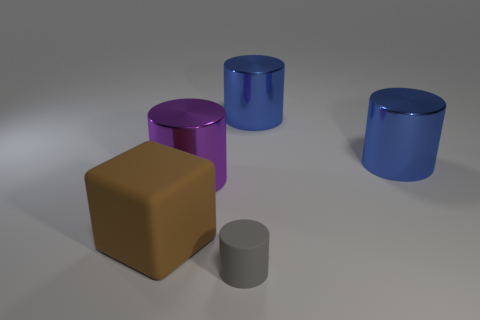Add 2 rubber cylinders. How many objects exist? 7 Subtract all blocks. How many objects are left? 4 Add 2 gray cylinders. How many gray cylinders exist? 3 Subtract 0 cyan cylinders. How many objects are left? 5 Subtract all large blocks. Subtract all matte things. How many objects are left? 2 Add 5 rubber blocks. How many rubber blocks are left? 6 